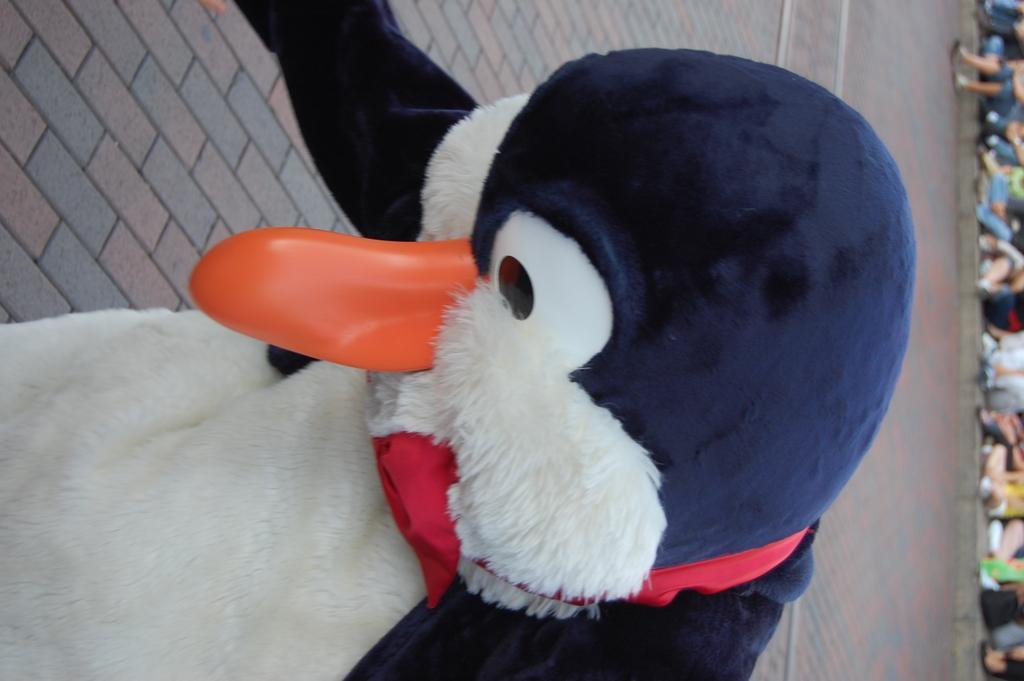How would you summarize this image in a sentence or two? In this image in the front there is a person wearing a costume of penguin and the background is blurry. 